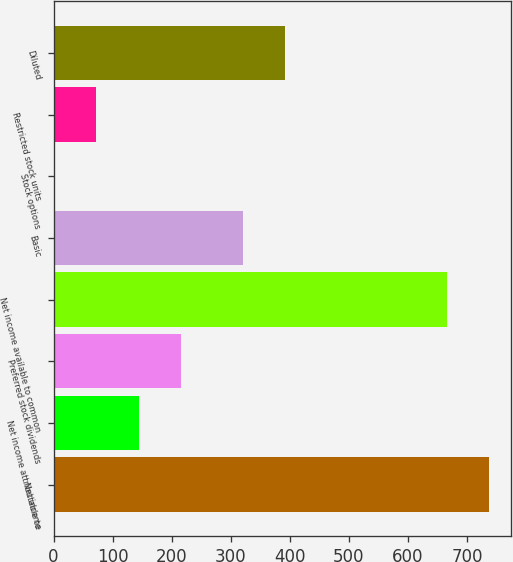<chart> <loc_0><loc_0><loc_500><loc_500><bar_chart><fcel>Net income<fcel>Net income attributable to<fcel>Preferred stock dividends<fcel>Net income available to common<fcel>Basic<fcel>Stock options<fcel>Restricted stock units<fcel>Diluted<nl><fcel>737.93<fcel>144.16<fcel>215.79<fcel>666.3<fcel>320.3<fcel>0.9<fcel>72.53<fcel>391.93<nl></chart> 